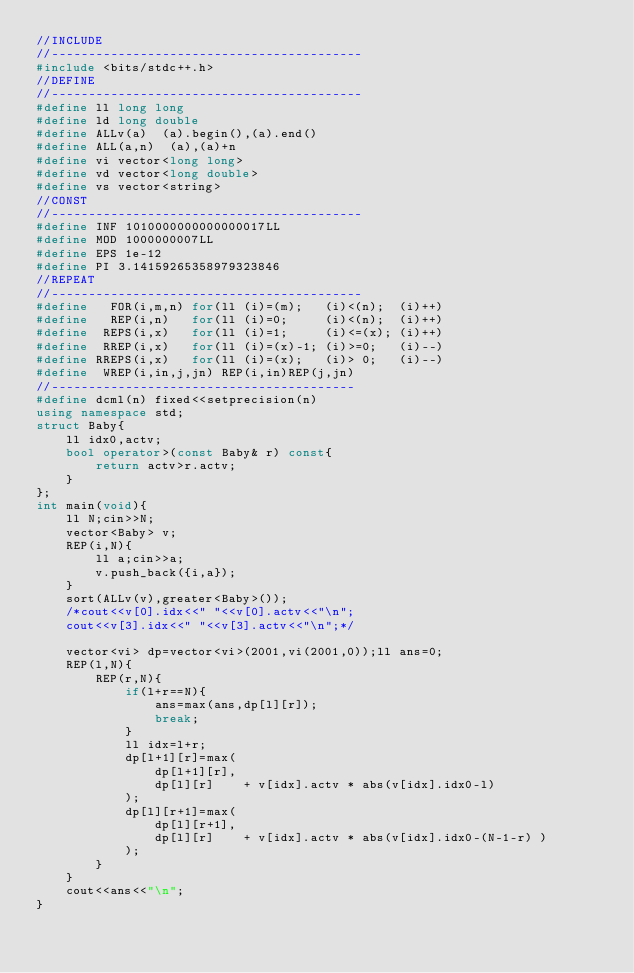<code> <loc_0><loc_0><loc_500><loc_500><_C++_>//INCLUDE
//------------------------------------------
#include <bits/stdc++.h>
//DEFINE
//------------------------------------------
#define ll long long
#define ld long double
#define ALLv(a)  (a).begin(),(a).end()
#define ALL(a,n)  (a),(a)+n
#define vi vector<long long>
#define vd vector<long double>
#define vs vector<string>
//CONST
//------------------------------------------
#define INF 1010000000000000017LL
#define MOD 1000000007LL
#define EPS 1e-12
#define PI 3.14159265358979323846
//REPEAT
//------------------------------------------
#define   FOR(i,m,n) for(ll (i)=(m);   (i)<(n);  (i)++)
#define   REP(i,n)   for(ll (i)=0;     (i)<(n);  (i)++)
#define  REPS(i,x)   for(ll (i)=1;     (i)<=(x); (i)++)
#define  RREP(i,x)   for(ll (i)=(x)-1; (i)>=0;   (i)--)
#define RREPS(i,x)   for(ll (i)=(x);   (i)> 0;   (i)--)
#define  WREP(i,in,j,jn) REP(i,in)REP(j,jn)
//-----------------------------------------
#define dcml(n) fixed<<setprecision(n)
using namespace std;
struct Baby{
    ll idx0,actv;
    bool operator>(const Baby& r) const{
        return actv>r.actv;
    }
};
int main(void){
    ll N;cin>>N;
    vector<Baby> v;
    REP(i,N){
        ll a;cin>>a;
        v.push_back({i,a});
    }
    sort(ALLv(v),greater<Baby>());
    /*cout<<v[0].idx<<" "<<v[0].actv<<"\n";
    cout<<v[3].idx<<" "<<v[3].actv<<"\n";*/
    
    vector<vi> dp=vector<vi>(2001,vi(2001,0));ll ans=0;
    REP(l,N){
        REP(r,N){
            if(l+r==N){
                ans=max(ans,dp[l][r]);
                break;
            }
            ll idx=l+r;
            dp[l+1][r]=max(
                dp[l+1][r],
                dp[l][r]    + v[idx].actv * abs(v[idx].idx0-l)
            );
            dp[l][r+1]=max(
                dp[l][r+1],
                dp[l][r]    + v[idx].actv * abs(v[idx].idx0-(N-1-r) )
            );
        }
    }
    cout<<ans<<"\n";
}</code> 